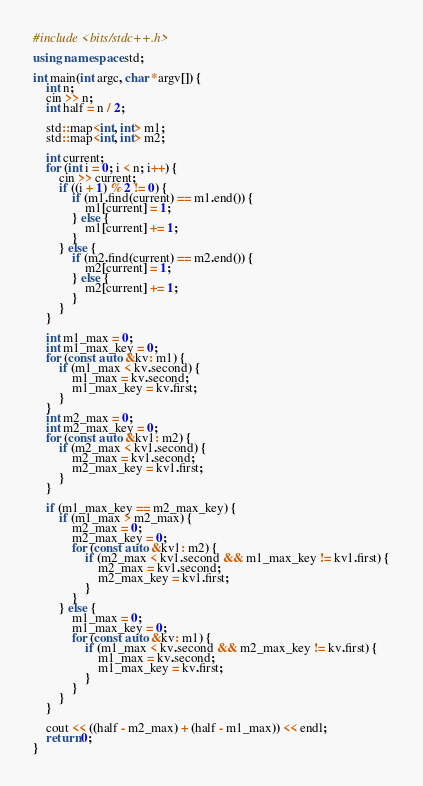<code> <loc_0><loc_0><loc_500><loc_500><_C++_>#include <bits/stdc++.h>

using namespace std;

int main(int argc, char *argv[]) {
	int n;
	cin >> n;
	int half = n / 2;

	std::map<int, int> m1;
	std::map<int, int> m2;

	int current;
	for (int i = 0; i < n; i++) {
		cin >> current;
		if ((i + 1) % 2 != 0) { 
			if (m1.find(current) == m1.end()) {
				m1[current] = 1;
			} else {
				m1[current] += 1;
			}
		} else {
			if (m2.find(current) == m2.end()) {
				m2[current] = 1;
			} else {
				m2[current] += 1;
			}
		}
	}

	int m1_max = 0;
	int m1_max_key = 0;
	for (const auto &kv: m1) {
		if (m1_max < kv.second) {
			m1_max = kv.second;
			m1_max_key = kv.first;
		}
	}
	int m2_max = 0;
	int m2_max_key = 0;
	for (const auto &kv1: m2) {
		if (m2_max < kv1.second) {
			m2_max = kv1.second;
			m2_max_key = kv1.first;
		}
	}

	if (m1_max_key == m2_max_key) {
		if (m1_max > m2_max) {
			m2_max = 0;
			m2_max_key = 0;
			for (const auto &kv1: m2) {
				if (m2_max < kv1.second && m1_max_key != kv1.first) {
					m2_max = kv1.second;
					m2_max_key = kv1.first;
				}
			}
		} else {
			m1_max = 0;
			m1_max_key = 0;
			for (const auto &kv: m1) {
				if (m1_max < kv.second && m2_max_key != kv.first) {
					m1_max = kv.second;
					m1_max_key = kv.first;
				}
			}
		}
	}

	cout << ((half - m2_max) + (half - m1_max)) << endl;
	return 0;
}
</code> 